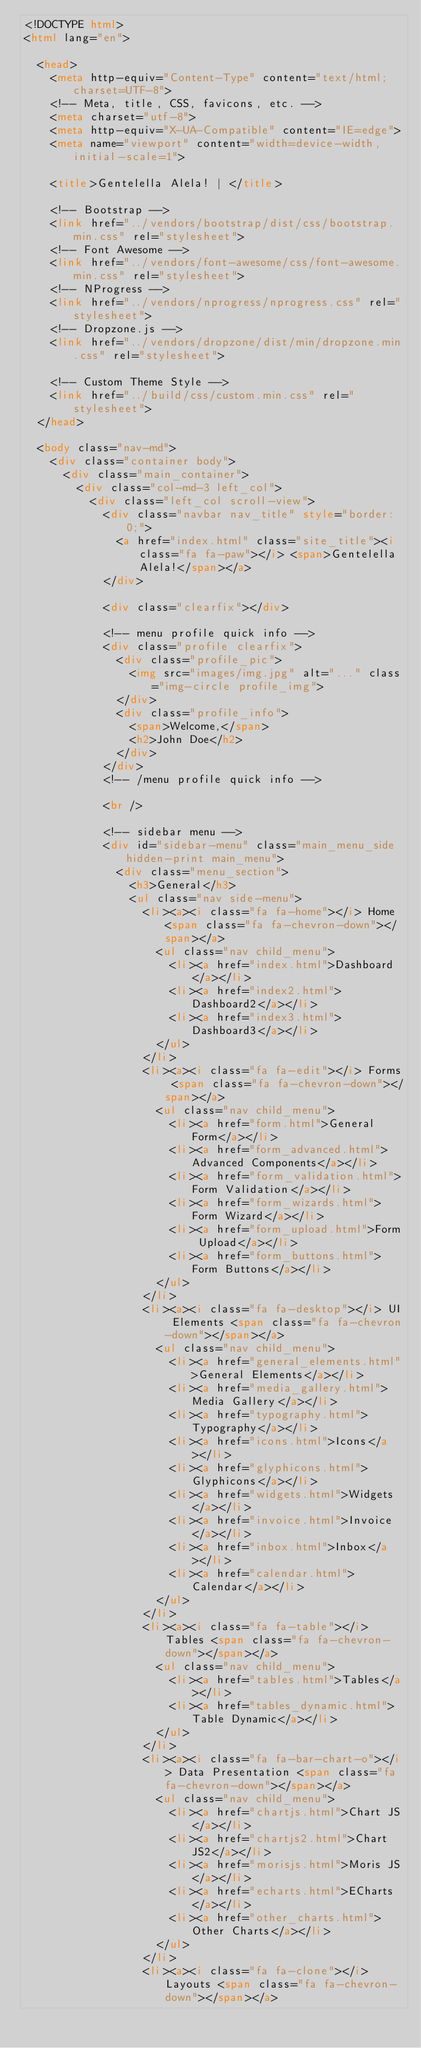<code> <loc_0><loc_0><loc_500><loc_500><_HTML_><!DOCTYPE html>
<html lang="en">

  <head>
    <meta http-equiv="Content-Type" content="text/html; charset=UTF-8">
    <!-- Meta, title, CSS, favicons, etc. -->
    <meta charset="utf-8">
    <meta http-equiv="X-UA-Compatible" content="IE=edge">
    <meta name="viewport" content="width=device-width, initial-scale=1">

    <title>Gentelella Alela! | </title>

    <!-- Bootstrap -->
    <link href="../vendors/bootstrap/dist/css/bootstrap.min.css" rel="stylesheet">
    <!-- Font Awesome -->
    <link href="../vendors/font-awesome/css/font-awesome.min.css" rel="stylesheet">
    <!-- NProgress -->
    <link href="../vendors/nprogress/nprogress.css" rel="stylesheet">
    <!-- Dropzone.js -->
    <link href="../vendors/dropzone/dist/min/dropzone.min.css" rel="stylesheet">

    <!-- Custom Theme Style -->
    <link href="../build/css/custom.min.css" rel="stylesheet">
  </head>

  <body class="nav-md">
    <div class="container body">
      <div class="main_container">
        <div class="col-md-3 left_col">
          <div class="left_col scroll-view">
            <div class="navbar nav_title" style="border: 0;">
              <a href="index.html" class="site_title"><i class="fa fa-paw"></i> <span>Gentelella Alela!</span></a>
            </div>

            <div class="clearfix"></div>

            <!-- menu profile quick info -->
            <div class="profile clearfix">
              <div class="profile_pic">
                <img src="images/img.jpg" alt="..." class="img-circle profile_img">
              </div>
              <div class="profile_info">
                <span>Welcome,</span>
                <h2>John Doe</h2>
              </div>
            </div>
            <!-- /menu profile quick info -->

            <br />

            <!-- sidebar menu -->
            <div id="sidebar-menu" class="main_menu_side hidden-print main_menu">
              <div class="menu_section">
                <h3>General</h3>
                <ul class="nav side-menu">
                  <li><a><i class="fa fa-home"></i> Home <span class="fa fa-chevron-down"></span></a>
                    <ul class="nav child_menu">
                      <li><a href="index.html">Dashboard</a></li>
                      <li><a href="index2.html">Dashboard2</a></li>
                      <li><a href="index3.html">Dashboard3</a></li>
                    </ul>
                  </li>
                  <li><a><i class="fa fa-edit"></i> Forms <span class="fa fa-chevron-down"></span></a>
                    <ul class="nav child_menu">
                      <li><a href="form.html">General Form</a></li>
                      <li><a href="form_advanced.html">Advanced Components</a></li>
                      <li><a href="form_validation.html">Form Validation</a></li>
                      <li><a href="form_wizards.html">Form Wizard</a></li>
                      <li><a href="form_upload.html">Form Upload</a></li>
                      <li><a href="form_buttons.html">Form Buttons</a></li>
                    </ul>
                  </li>
                  <li><a><i class="fa fa-desktop"></i> UI Elements <span class="fa fa-chevron-down"></span></a>
                    <ul class="nav child_menu">
                      <li><a href="general_elements.html">General Elements</a></li>
                      <li><a href="media_gallery.html">Media Gallery</a></li>
                      <li><a href="typography.html">Typography</a></li>
                      <li><a href="icons.html">Icons</a></li>
                      <li><a href="glyphicons.html">Glyphicons</a></li>
                      <li><a href="widgets.html">Widgets</a></li>
                      <li><a href="invoice.html">Invoice</a></li>
                      <li><a href="inbox.html">Inbox</a></li>
                      <li><a href="calendar.html">Calendar</a></li>
                    </ul>
                  </li>
                  <li><a><i class="fa fa-table"></i> Tables <span class="fa fa-chevron-down"></span></a>
                    <ul class="nav child_menu">
                      <li><a href="tables.html">Tables</a></li>
                      <li><a href="tables_dynamic.html">Table Dynamic</a></li>
                    </ul>
                  </li>
                  <li><a><i class="fa fa-bar-chart-o"></i> Data Presentation <span class="fa fa-chevron-down"></span></a>
                    <ul class="nav child_menu">
                      <li><a href="chartjs.html">Chart JS</a></li>
                      <li><a href="chartjs2.html">Chart JS2</a></li>
                      <li><a href="morisjs.html">Moris JS</a></li>
                      <li><a href="echarts.html">ECharts</a></li>
                      <li><a href="other_charts.html">Other Charts</a></li>
                    </ul>
                  </li>
                  <li><a><i class="fa fa-clone"></i>Layouts <span class="fa fa-chevron-down"></span></a></code> 